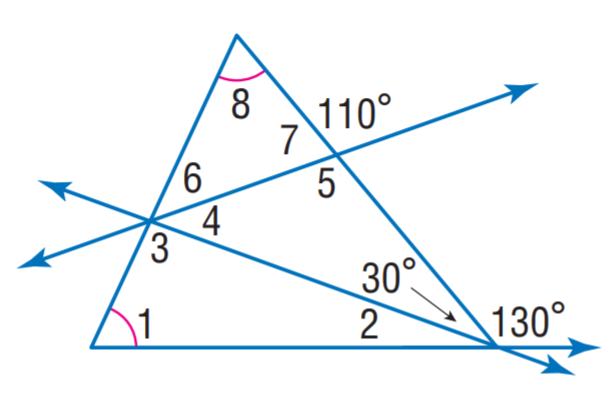Answer the mathemtical geometry problem and directly provide the correct option letter.
Question: Find m \angle 3.
Choices: A: 65 B: 70 C: 95 D: 110 C 